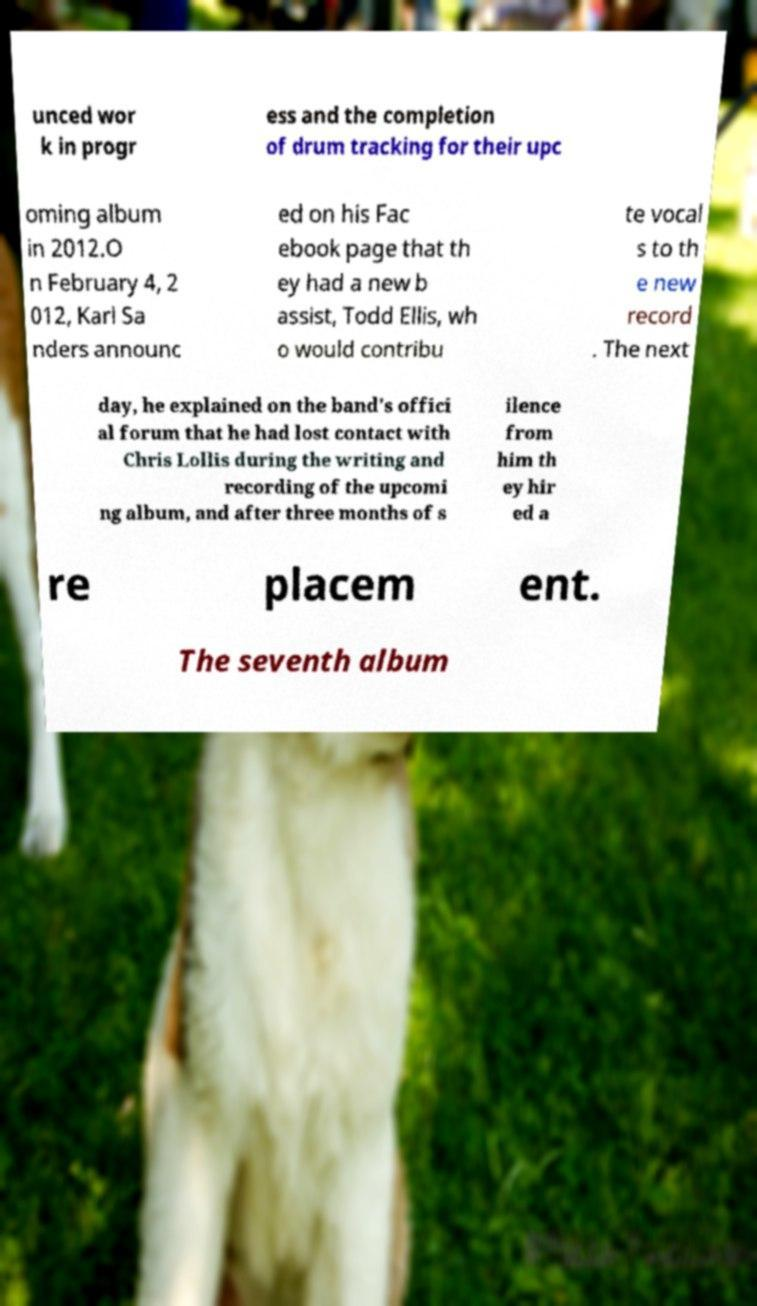What messages or text are displayed in this image? I need them in a readable, typed format. unced wor k in progr ess and the completion of drum tracking for their upc oming album in 2012.O n February 4, 2 012, Karl Sa nders announc ed on his Fac ebook page that th ey had a new b assist, Todd Ellis, wh o would contribu te vocal s to th e new record . The next day, he explained on the band's offici al forum that he had lost contact with Chris Lollis during the writing and recording of the upcomi ng album, and after three months of s ilence from him th ey hir ed a re placem ent. The seventh album 